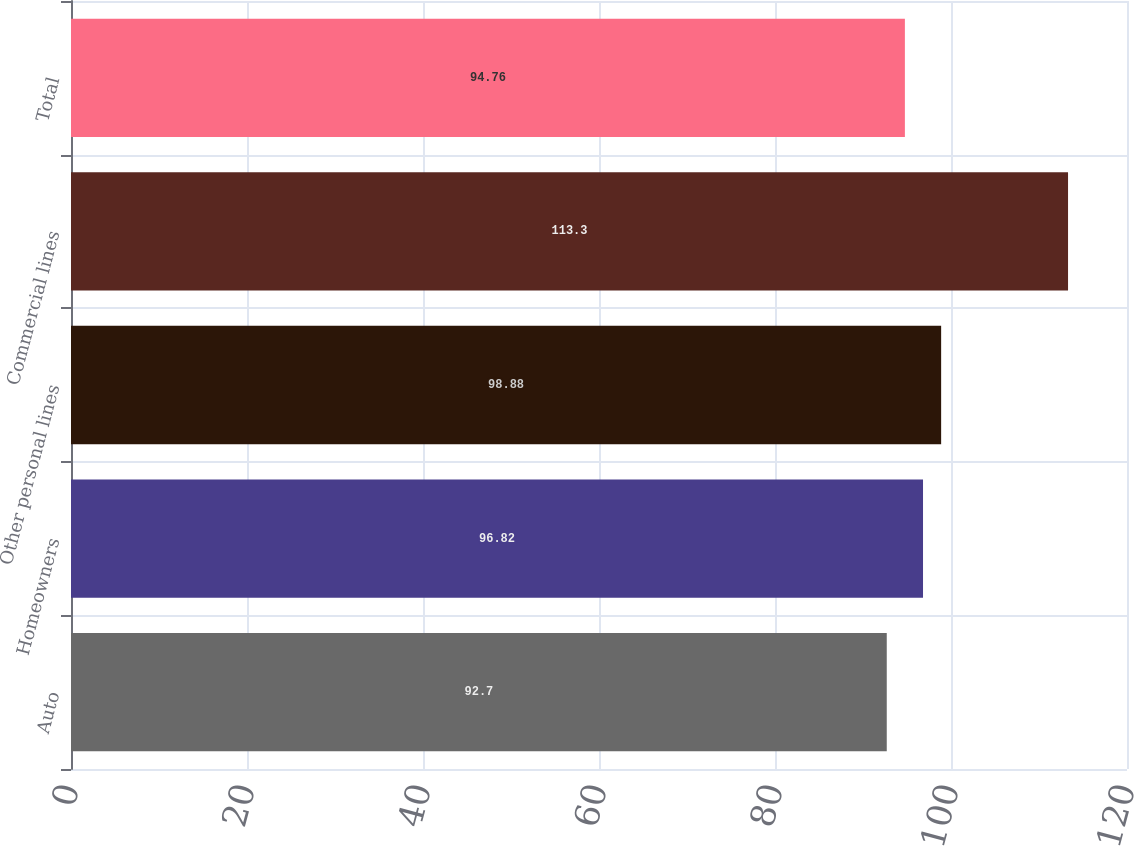Convert chart. <chart><loc_0><loc_0><loc_500><loc_500><bar_chart><fcel>Auto<fcel>Homeowners<fcel>Other personal lines<fcel>Commercial lines<fcel>Total<nl><fcel>92.7<fcel>96.82<fcel>98.88<fcel>113.3<fcel>94.76<nl></chart> 